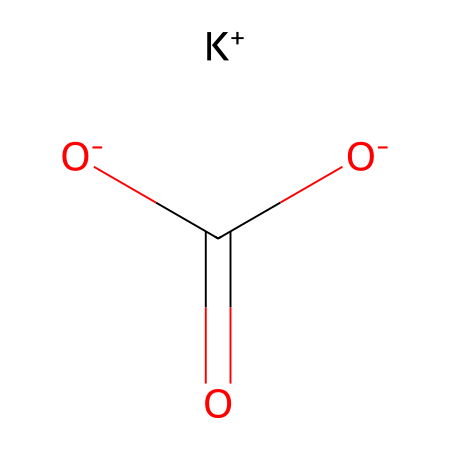What is the chemical name of this compound? The SMILES representation indicates that this compound contains a potassium cation (K+) and a bicarbonate anion ([O-]C(=O)[O-]), which together identify it as potassium bicarbonate.
Answer: potassium bicarbonate How many oxygen atoms are present in this molecule? Looking at the bicarbonate anion structure, there are three oxygen atoms: two from the carboxylate group and one from the carbonate part.
Answer: three What is the charge of the potassium ion in this molecule? The SMILES shows the potassium ion as K+, which indicates that it has a positive charge.
Answer: positive What role does this compound play in antacids? Potassium bicarbonate reacts with stomach acid (HCl) to neutralize it, making it effective in alleviating heartburn and indigestion, which is the role of antacids.
Answer: neutralizing agent How many total atoms are in potassium bicarbonate? In the structure, there is one potassium atom, one carbon atom, three oxygen atoms, and one hydrogen atom, totaling five atoms in the compound.
Answer: five What type of electrolyte is potassium bicarbonate classified as? It is considered a strong electrolyte because it dissociates completely into potassium ions and bicarbonate ions in solution.
Answer: strong What is the presence of the bicarbonate ion indicative of in terms of pH? The presence of bicarbonate ions tends to indicate that the solution can act as a buffer, helping to maintain a relatively stable pH when acid is added.
Answer: buffer agent 